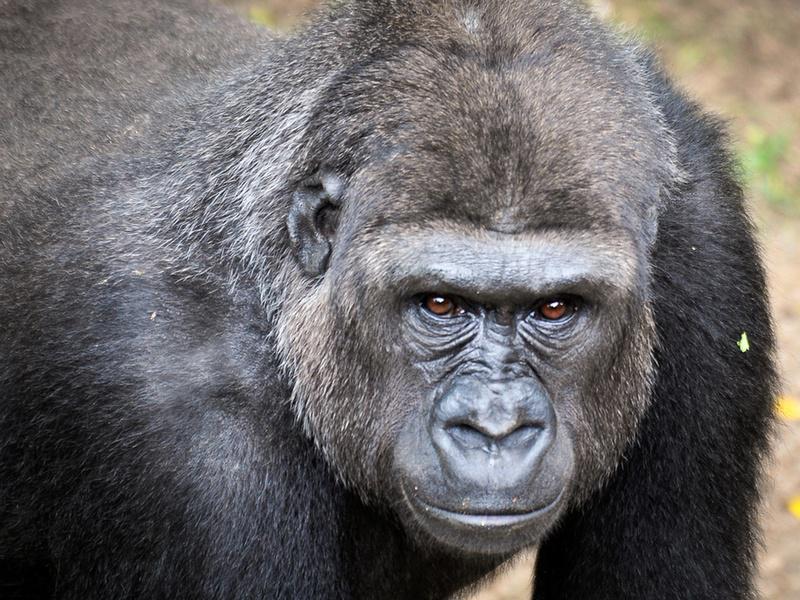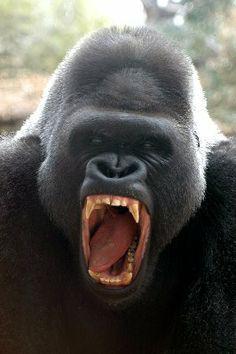The first image is the image on the left, the second image is the image on the right. Evaluate the accuracy of this statement regarding the images: "In at least one image there is a gorilla with his mouth wide open.". Is it true? Answer yes or no. Yes. The first image is the image on the left, the second image is the image on the right. Evaluate the accuracy of this statement regarding the images: "An ape has its mouth open.". Is it true? Answer yes or no. Yes. 